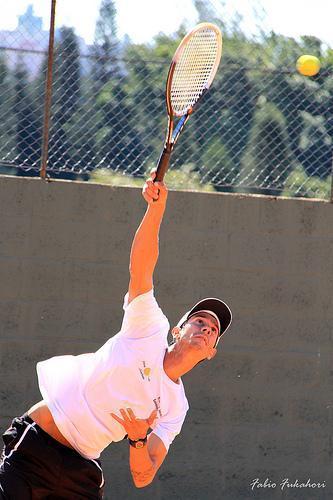How many people are in this picture?
Give a very brief answer. 1. How many people are pictured?
Give a very brief answer. 1. 